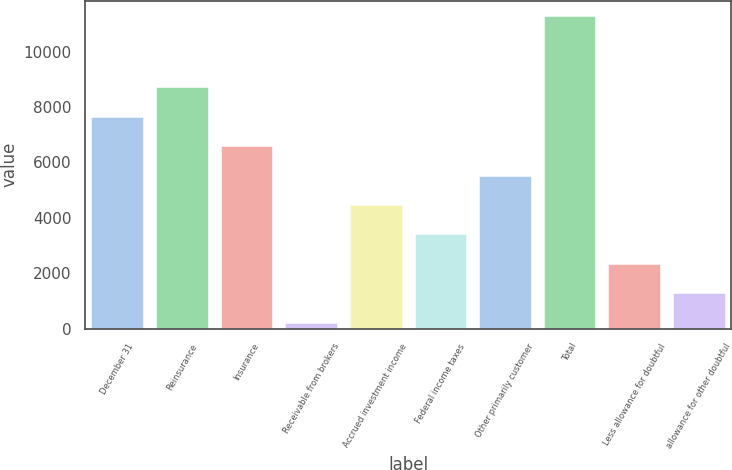Convert chart to OTSL. <chart><loc_0><loc_0><loc_500><loc_500><bar_chart><fcel>December 31<fcel>Reinsurance<fcel>Insurance<fcel>Receivable from brokers<fcel>Accrued investment income<fcel>Federal income taxes<fcel>Other primarily customer<fcel>Total<fcel>Less allowance for doubtful<fcel>allowance for other doubtful<nl><fcel>7644.5<fcel>8705<fcel>6584<fcel>221<fcel>4463<fcel>3402.5<fcel>5523.5<fcel>11272.5<fcel>2342<fcel>1281.5<nl></chart> 